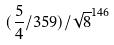Convert formula to latex. <formula><loc_0><loc_0><loc_500><loc_500>( \frac { 5 } { 4 } / 3 5 9 ) / \sqrt { 8 } ^ { 1 4 6 }</formula> 